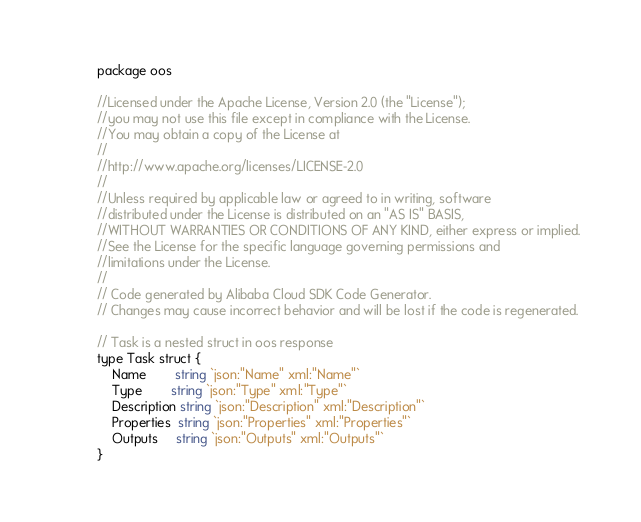Convert code to text. <code><loc_0><loc_0><loc_500><loc_500><_Go_>package oos

//Licensed under the Apache License, Version 2.0 (the "License");
//you may not use this file except in compliance with the License.
//You may obtain a copy of the License at
//
//http://www.apache.org/licenses/LICENSE-2.0
//
//Unless required by applicable law or agreed to in writing, software
//distributed under the License is distributed on an "AS IS" BASIS,
//WITHOUT WARRANTIES OR CONDITIONS OF ANY KIND, either express or implied.
//See the License for the specific language governing permissions and
//limitations under the License.
//
// Code generated by Alibaba Cloud SDK Code Generator.
// Changes may cause incorrect behavior and will be lost if the code is regenerated.

// Task is a nested struct in oos response
type Task struct {
	Name        string `json:"Name" xml:"Name"`
	Type        string `json:"Type" xml:"Type"`
	Description string `json:"Description" xml:"Description"`
	Properties  string `json:"Properties" xml:"Properties"`
	Outputs     string `json:"Outputs" xml:"Outputs"`
}
</code> 